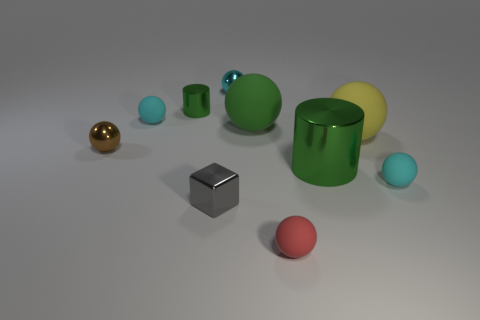Is there any other thing that is the same shape as the gray shiny thing?
Ensure brevity in your answer.  No. What is the shape of the cyan matte thing in front of the green cylinder right of the green matte thing?
Provide a short and direct response. Sphere. What is the shape of the small cyan object that is the same material as the small brown ball?
Provide a succinct answer. Sphere. What is the size of the ball in front of the cyan rubber sphere that is in front of the small brown shiny ball?
Your answer should be very brief. Small. What shape is the small brown object?
Your response must be concise. Sphere. How many small objects are purple metallic balls or brown spheres?
Provide a short and direct response. 1. There is a brown metallic object that is the same shape as the green matte thing; what size is it?
Provide a succinct answer. Small. How many matte things are both to the left of the large cylinder and behind the large green cylinder?
Your response must be concise. 2. There is a green matte object; does it have the same shape as the small object right of the large shiny object?
Your response must be concise. Yes. Are there more yellow spheres that are behind the big yellow ball than gray metal cylinders?
Your answer should be very brief. No. 